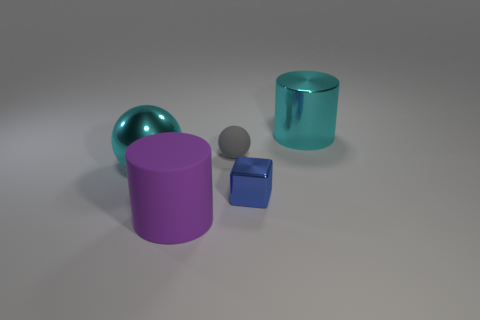Add 4 small metal cubes. How many objects exist? 9 Subtract all balls. How many objects are left? 3 Subtract all tiny matte balls. Subtract all gray rubber spheres. How many objects are left? 3 Add 4 small spheres. How many small spheres are left? 5 Add 5 yellow spheres. How many yellow spheres exist? 5 Subtract 0 yellow cylinders. How many objects are left? 5 